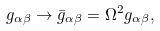<formula> <loc_0><loc_0><loc_500><loc_500>g _ { \alpha \beta } \rightarrow \bar { g } _ { \alpha \beta } = \Omega ^ { 2 } g _ { \alpha \beta } ,</formula> 